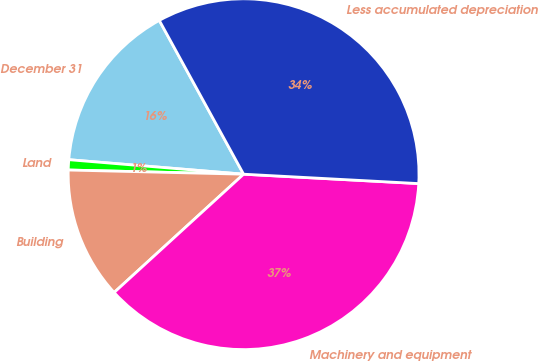<chart> <loc_0><loc_0><loc_500><loc_500><pie_chart><fcel>December 31<fcel>Land<fcel>Building<fcel>Machinery and equipment<fcel>Less accumulated depreciation<nl><fcel>15.7%<fcel>0.94%<fcel>12.16%<fcel>37.36%<fcel>33.83%<nl></chart> 